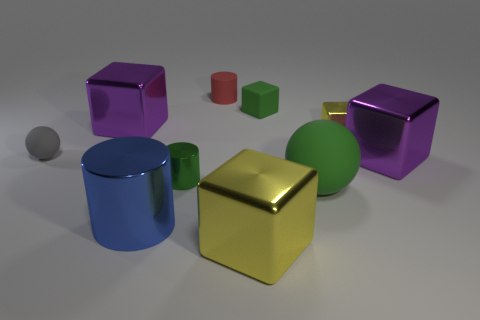There is a green object that is both on the right side of the tiny red rubber thing and to the left of the large green rubber thing; what size is it?
Your response must be concise. Small. Are there fewer large rubber balls that are behind the tiny red cylinder than small green metallic objects?
Ensure brevity in your answer.  Yes. There is a tiny red object that is the same material as the gray sphere; what is its shape?
Make the answer very short. Cylinder. There is a purple metallic thing behind the small yellow thing; is its shape the same as the purple metal thing that is on the right side of the rubber block?
Provide a short and direct response. Yes. Are there fewer big green balls that are behind the green matte sphere than small cubes that are on the left side of the tiny matte block?
Offer a terse response. No. What is the shape of the matte object that is the same color as the tiny matte block?
Give a very brief answer. Sphere. How many red rubber cylinders are the same size as the blue shiny cylinder?
Your response must be concise. 0. Is the material of the big cube that is on the right side of the big green matte thing the same as the big green ball?
Make the answer very short. No. Are there any big green shiny things?
Keep it short and to the point. No. What size is the green object that is made of the same material as the blue cylinder?
Your answer should be compact. Small. 